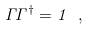<formula> <loc_0><loc_0><loc_500><loc_500>\Gamma \Gamma ^ { \dagger } = { 1 } \ ,</formula> 